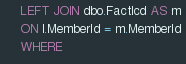<code> <loc_0><loc_0><loc_500><loc_500><_SQL_>	LEFT JOIN dbo.FactIcd AS m
	ON l.MemberId = m.MemberId
	WHERE</code> 